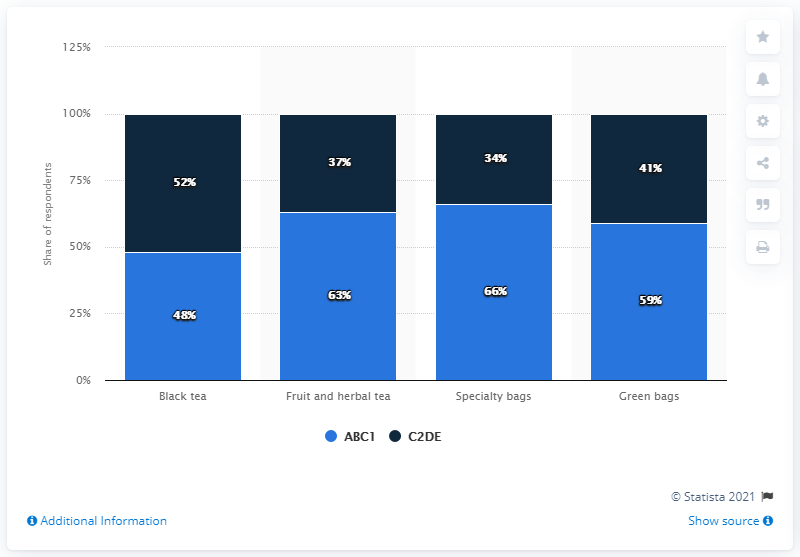Indicate a few pertinent items in this graphic. Among the ABC1 respondents, 66% consume specialty bags. According to the data, 34% of respondents from the C2DE group consume specialty bags. 